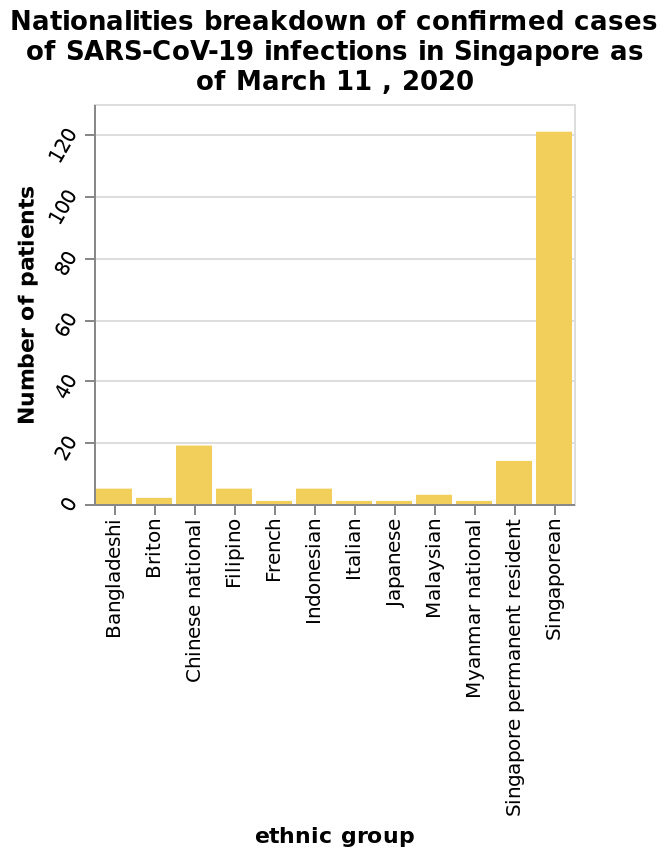<image>
What is the name of the bar diagram provided?  The bar diagram is named "Nationalities breakdown of confirmed cases of SARS-CoV-19 infections in Singapore as of March 11, 2020".  In terms of covid cases, which countries had the lowest numbers according to the figure?  According to the figure, the countries with the lowest numbers of covid cases were the French, Italian, and Japanese. 